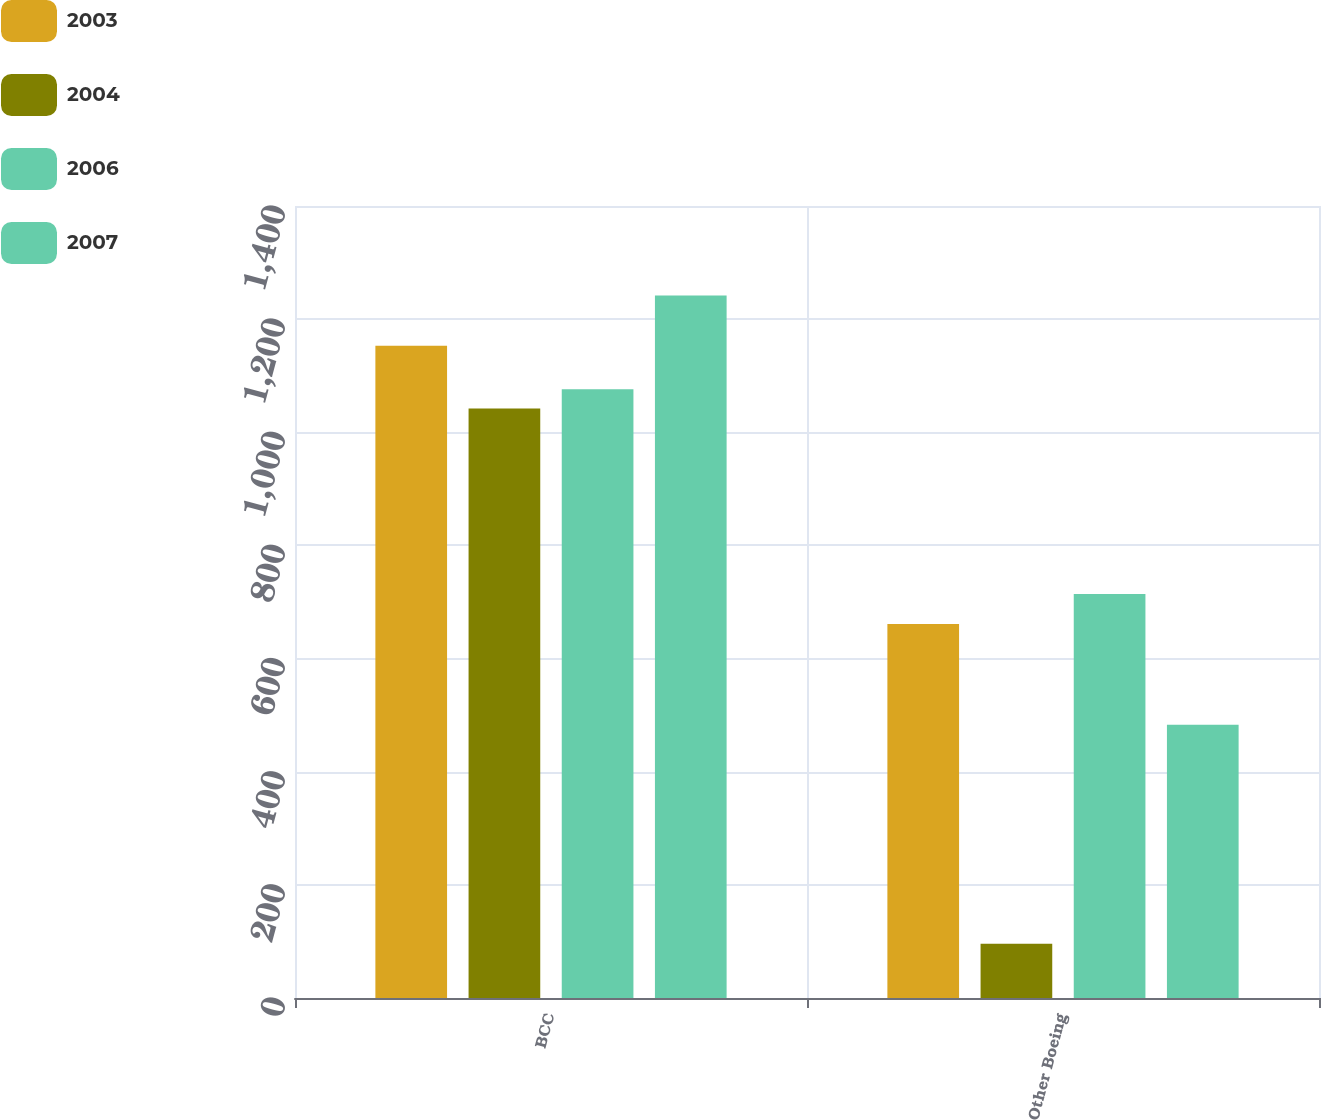Convert chart. <chart><loc_0><loc_0><loc_500><loc_500><stacked_bar_chart><ecel><fcel>BCC<fcel>Other Boeing<nl><fcel>2003<fcel>1153<fcel>661<nl><fcel>2004<fcel>1042<fcel>96<nl><fcel>2006<fcel>1076<fcel>714<nl><fcel>2007<fcel>1242<fcel>483<nl></chart> 